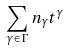Convert formula to latex. <formula><loc_0><loc_0><loc_500><loc_500>\sum _ { \gamma \in \Gamma } n _ { \gamma } t ^ { \gamma }</formula> 